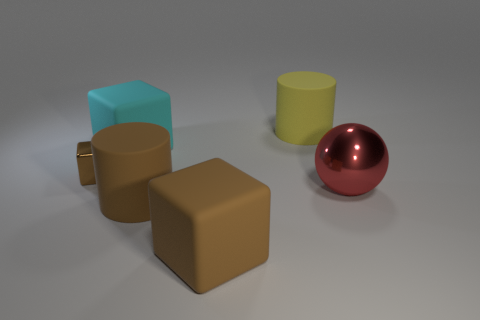Add 4 brown matte spheres. How many objects exist? 10 Subtract all balls. How many objects are left? 5 Add 2 yellow metallic objects. How many yellow metallic objects exist? 2 Subtract 1 yellow cylinders. How many objects are left? 5 Subtract all big yellow matte cylinders. Subtract all red things. How many objects are left? 4 Add 6 large cyan cubes. How many large cyan cubes are left? 7 